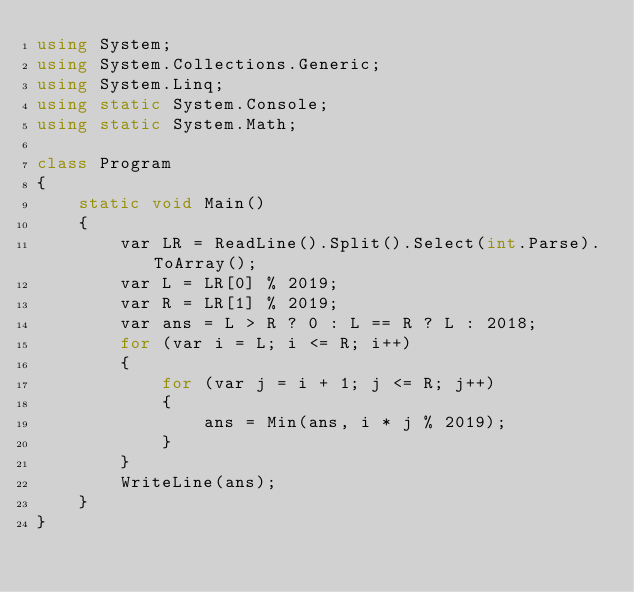<code> <loc_0><loc_0><loc_500><loc_500><_C#_>using System;
using System.Collections.Generic;
using System.Linq;
using static System.Console;
using static System.Math;

class Program
{
    static void Main()
    {
        var LR = ReadLine().Split().Select(int.Parse).ToArray();
        var L = LR[0] % 2019;
        var R = LR[1] % 2019;
        var ans = L > R ? 0 : L == R ? L : 2018;
        for (var i = L; i <= R; i++)
        {
            for (var j = i + 1; j <= R; j++)
            {
                ans = Min(ans, i * j % 2019);
            }
        }
        WriteLine(ans);
    }
}
</code> 